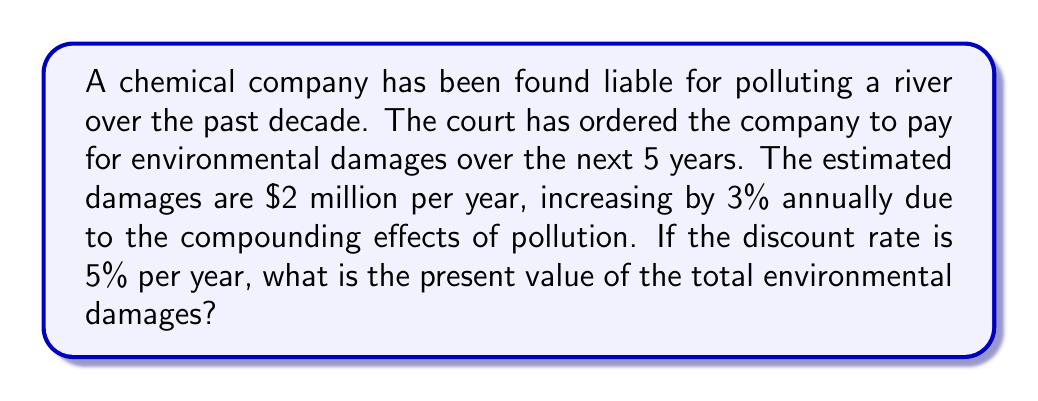Can you answer this question? To solve this problem, we need to use the discounted cash flow model to calculate the present value of future environmental damages. Let's break it down step by step:

1) First, let's calculate the damages for each year:
   Year 1: $2,000,000
   Year 2: $2,000,000 * 1.03 = $2,060,000
   Year 3: $2,060,000 * 1.03 = $2,121,800
   Year 4: $2,121,800 * 1.03 = $2,185,454
   Year 5: $2,185,454 * 1.03 = $2,251,017.62

2) Now, we need to discount each of these future values back to the present. The formula for present value is:

   $$ PV = \frac{FV}{(1+r)^n} $$

   Where PV is present value, FV is future value, r is the discount rate, and n is the number of years.

3) Let's calculate the present value for each year:

   Year 1: $\frac{2,000,000}{(1+0.05)^1} = 1,904,761.90$
   Year 2: $\frac{2,060,000}{(1+0.05)^2} = 1,868,027.21$
   Year 3: $\frac{2,121,800}{(1+0.05)^3} = 1,832,221.69$
   Year 4: $\frac{2,185,454}{(1+0.05)^4} = 1,797,328.73$
   Year 5: $\frac{2,251,017.62}{(1+0.05)^5} = 1,763,332.89$

4) The total present value is the sum of these individual present values:

   $1,904,761.90 + 1,868,027.21 + 1,832,221.69 + 1,797,328.73 + 1,763,332.89 = 9,165,672.42$

Therefore, the present value of the total environmental damages is approximately $9,165,672.42.
Answer: $9,165,672.42 